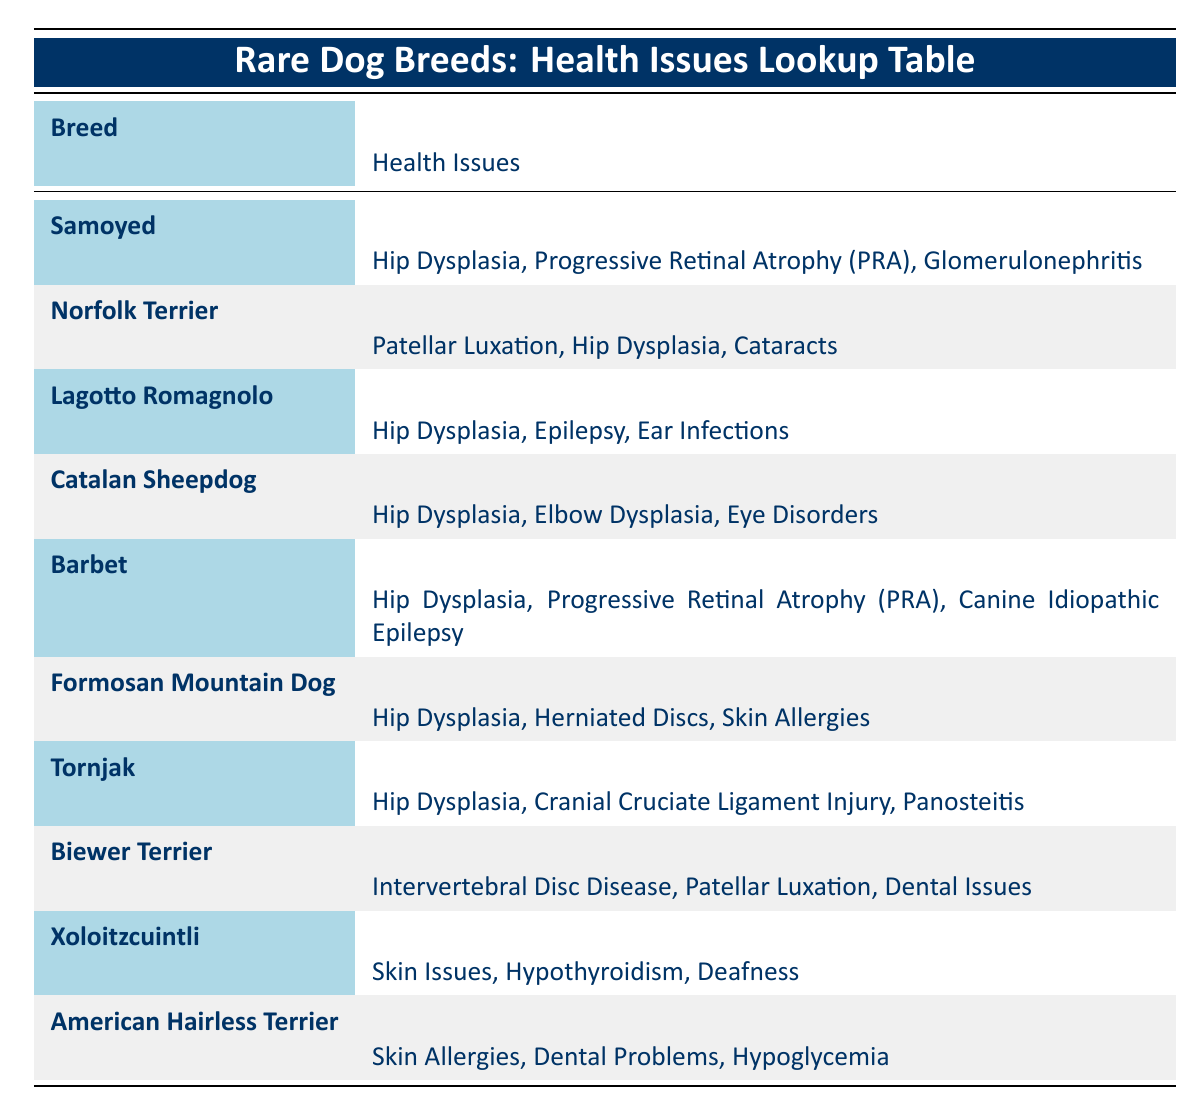What are the health issues associated with the Samoyed breed? The Samoyed has three recorded health issues: Hip Dysplasia, Progressive Retinal Atrophy (PRA), and Glomerulonephritis. These can be found in the row detailing the Samoyed in the table.
Answer: Hip Dysplasia, Progressive Retinal Atrophy (PRA), Glomerulonephritis Which dog breed has the most health issues listed in the table? From reviewing each breed's health issues, several breeds have three listed issues, and there are no breeds with more than three. Thus, all that have three are equal in count.
Answer: Equal count among multiple breeds (three issues each) Do both the Norfolk Terrier and the Lagotto Romagnolo have Hip Dysplasia as a health issue? Looking at the health issues listed for both breeds, both the Norfolk Terrier and the Lagotto Romagnolo have Hip Dysplasia as one of their conditions.
Answer: Yes How many breeds have skin-related health issues? The breeds with skin-related health issues include Xoloitzcuintli (Skin Issues) and American Hairless Terrier (Skin Allergies). Counting these gives a total of two breeds with such issues.
Answer: 2 Which health issue is commonly found among the breeds listed in the table? Upon checking each breed's health issues, it is clear that Hip Dysplasia appears in almost all entries (seven out of ten), indicating it as a common issue.
Answer: Hip Dysplasia Is it true that the Biewer Terrier has more than two health issues? The Biewer Terrier has three health issues listed in the table: Intervertebral Disc Disease, Patellar Luxation, and Dental Issues. There are not less than or equal to two.
Answer: Yes What is the average number of health issues across all listed breeds? Each breed has between two to three recorded health issues. As there are ten breeds, and seven have three issues each while three have two, the average can be calculated as: (7*3 + 3*2)/10 = (21+6)/10 = 27/10 = 2.7.
Answer: 2.7 Which breed has the health issue of Progressive Retinal Atrophy (PRA)? The breed Barbet and Samoyed both have Progressive Retinal Atrophy (PRA) listed as one of their health issues. This information can be pinpointed easily in their respective rows.
Answer: Barbet, Samoyed Does the Catalan Sheepdog have eye-related problems among its health issues? Yes, by examining the Catalan Sheepdog's health issues, Eye Disorders is explicitly mentioned as one of the conditions affecting this breed.
Answer: Yes 